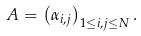<formula> <loc_0><loc_0><loc_500><loc_500>A = \left ( \alpha _ { i , j } \right ) _ { 1 \leq i , j \leq N } .</formula> 